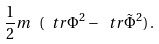<formula> <loc_0><loc_0><loc_500><loc_500>\frac { 1 } { 2 } m \ ( \ t r \Phi ^ { 2 } - \ t r \tilde { \Phi } ^ { 2 } ) \, .</formula> 